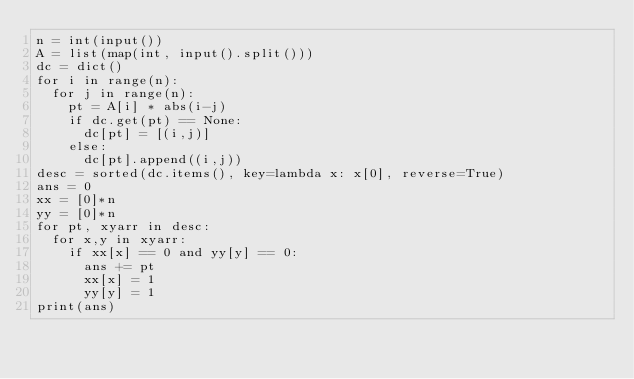Convert code to text. <code><loc_0><loc_0><loc_500><loc_500><_Python_>n = int(input())
A = list(map(int, input().split()))
dc = dict()
for i in range(n):
  for j in range(n):
    pt = A[i] * abs(i-j)
    if dc.get(pt) == None:
      dc[pt] = [(i,j)]
    else:
      dc[pt].append((i,j))
desc = sorted(dc.items(), key=lambda x: x[0], reverse=True)
ans = 0
xx = [0]*n
yy = [0]*n
for pt, xyarr in desc:
  for x,y in xyarr:
    if xx[x] == 0 and yy[y] == 0:
      ans += pt
      xx[x] = 1
      yy[y] = 1
print(ans)</code> 